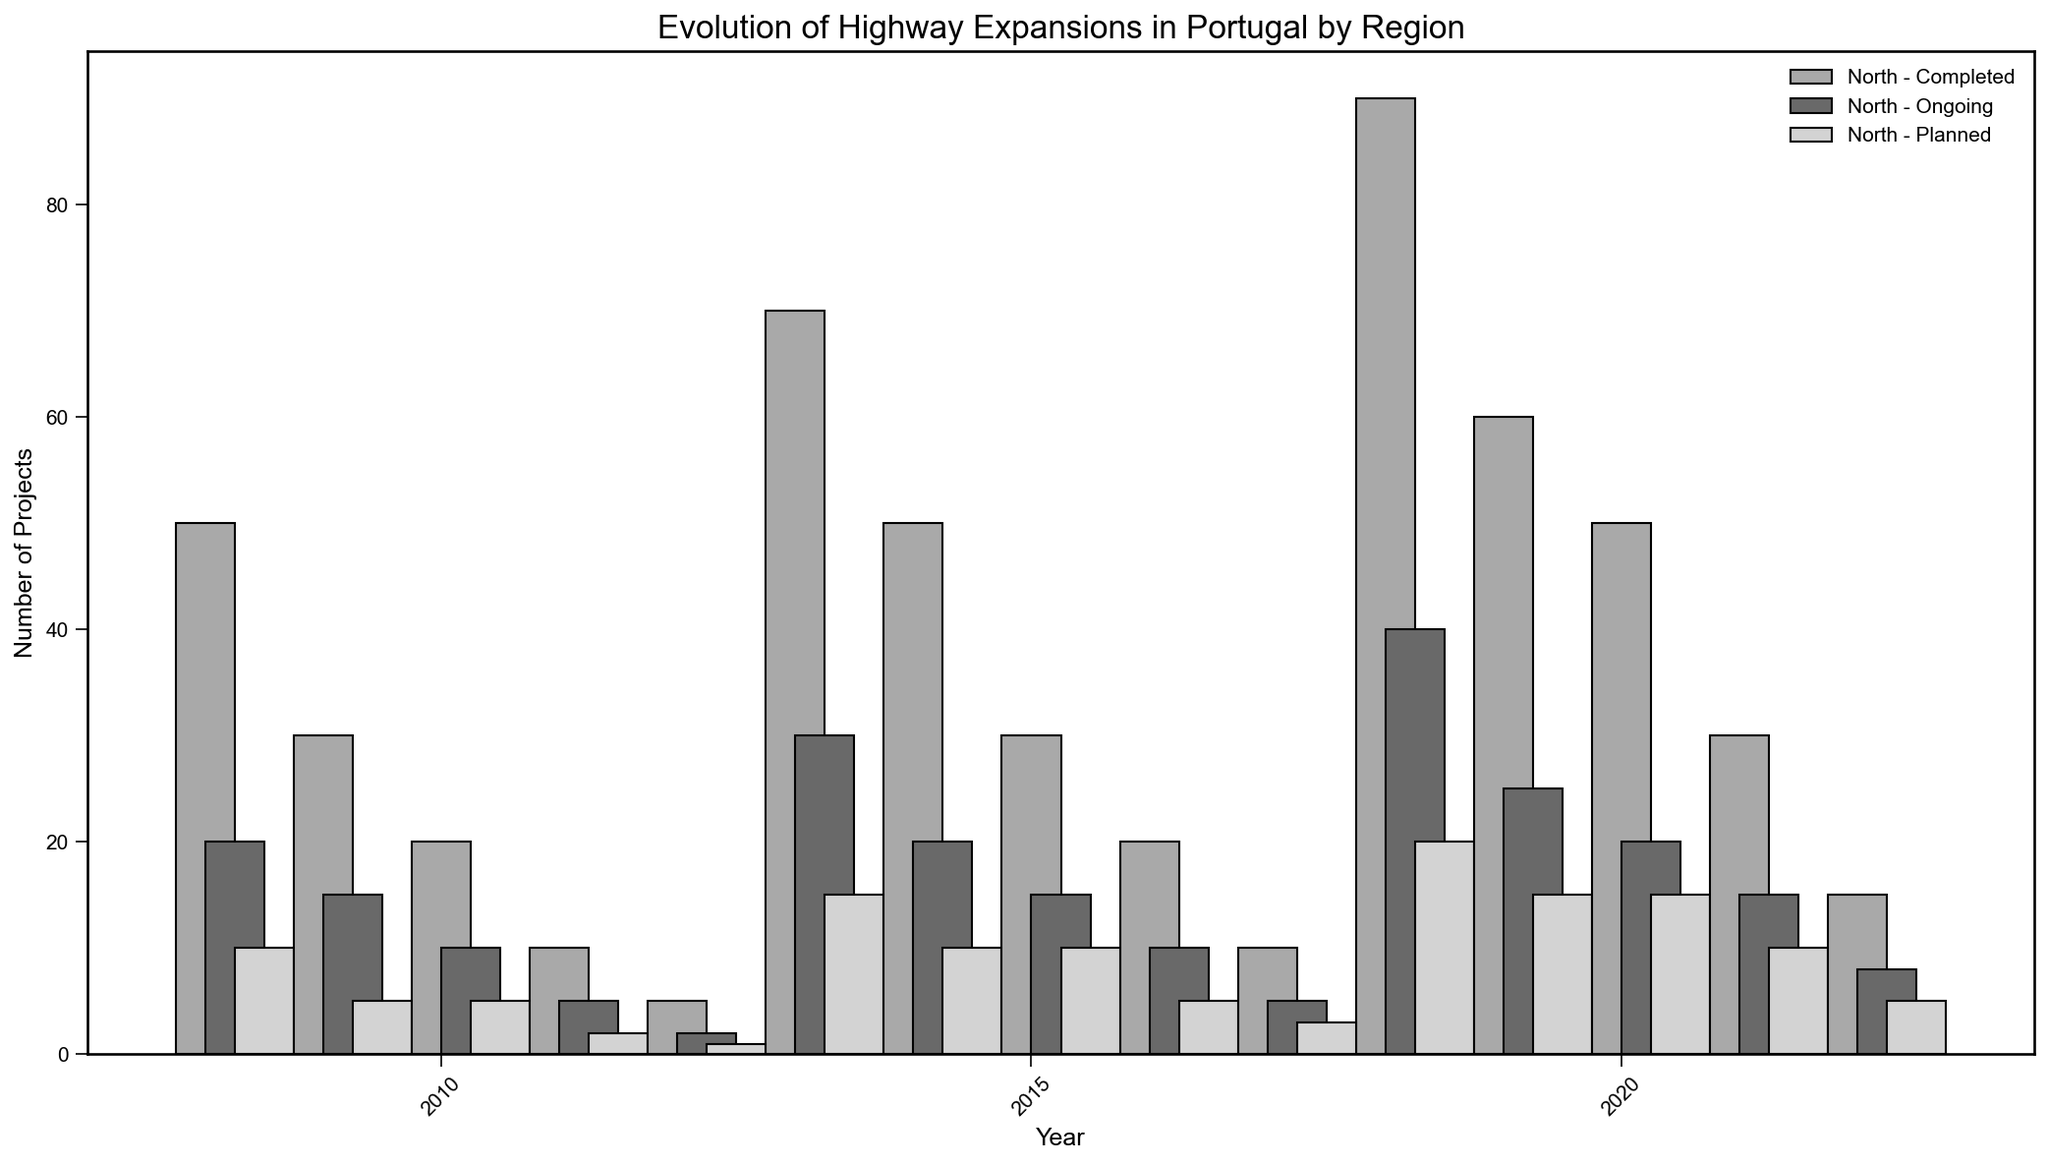Which region had the highest number of completed projects in 2020? To find the region with the highest number of completed projects in 2020, look at the bar heights labeled 'Completed' for each region in 2020. The North has the tallest bar.
Answer: North How did the number of ongoing projects in the Lisbon region change from 2010 to 2020? To observe the change, compare the heights of the bars labeled 'Ongoing' for Lisbon in 2010, 2015, and 2020. In 2010, there were 10 projects, in 2015 there were 15, and in 2020 there were again 20.
Answer: Increased Which region had the smallest increase in completed projects from 2010 to 2020? Calculate the increase in completed projects for each region by subtracting the 2010 value from the 2020 value. The values are: 
  - North: 90 - 50 = 40
  - Central: 60 - 30 = 30
  - Lisbon: 50 - 20 = 30
  - Alentejo: 30 - 10 = 20
  - Algarve: 15 - 5 = 10
  
The smallest increase is in Algarve.
Answer: Algarve In which year did the Central region have the highest number of ongoing projects? Look at the heights of the bars labeled 'Ongoing' for the Central region in all years. The highest is in 2020 with 25 projects.
Answer: 2020 Which region had the least number of ongoing projects in 2010? Look at the heights of the bars labeled 'Ongoing' for each region in 2010. The Algarve had the smallest bar with 2 projects.
Answer: Algarve 